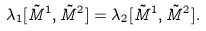<formula> <loc_0><loc_0><loc_500><loc_500>\lambda _ { 1 } [ \tilde { M } ^ { 1 } , \tilde { M } ^ { 2 } ] = \lambda _ { 2 } [ \tilde { M } ^ { 1 } , \tilde { M } ^ { 2 } ] .</formula> 